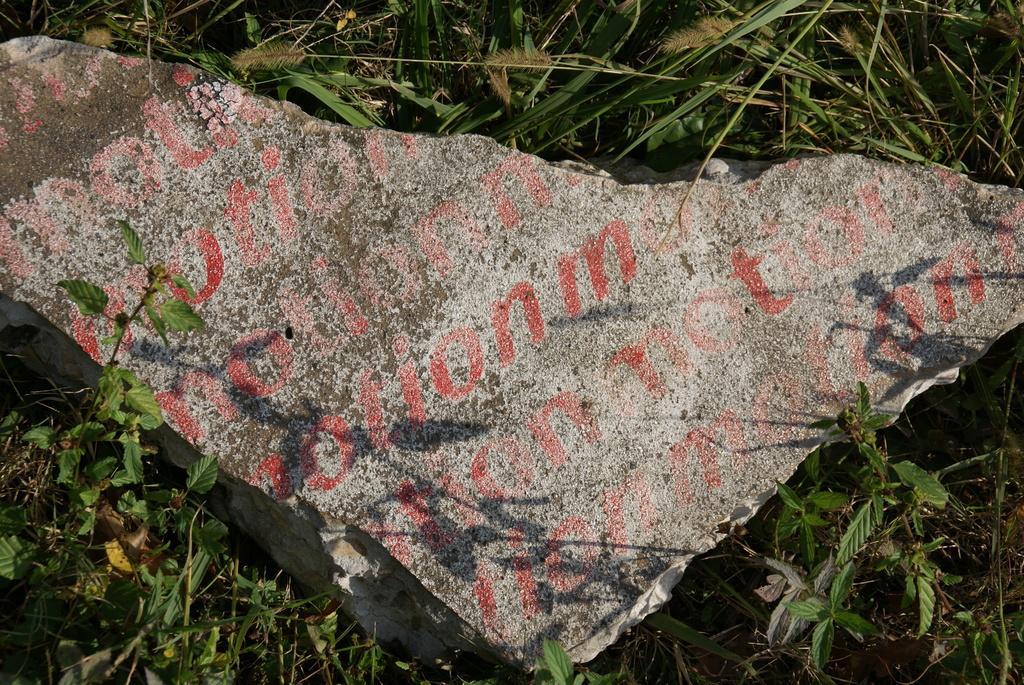What is the main subject in the center of the image? There is a stone in the center of the image. What type of vegetation can be seen at the bottom of the image? There are plants at the bottom of the image. What type of ground cover is present at the top of the image? Grass is present at the top of the image. What type of thrill can be experienced while wearing the vest in the image? There is no vest present in the image, and therefore no thrill can be experienced from wearing it. 